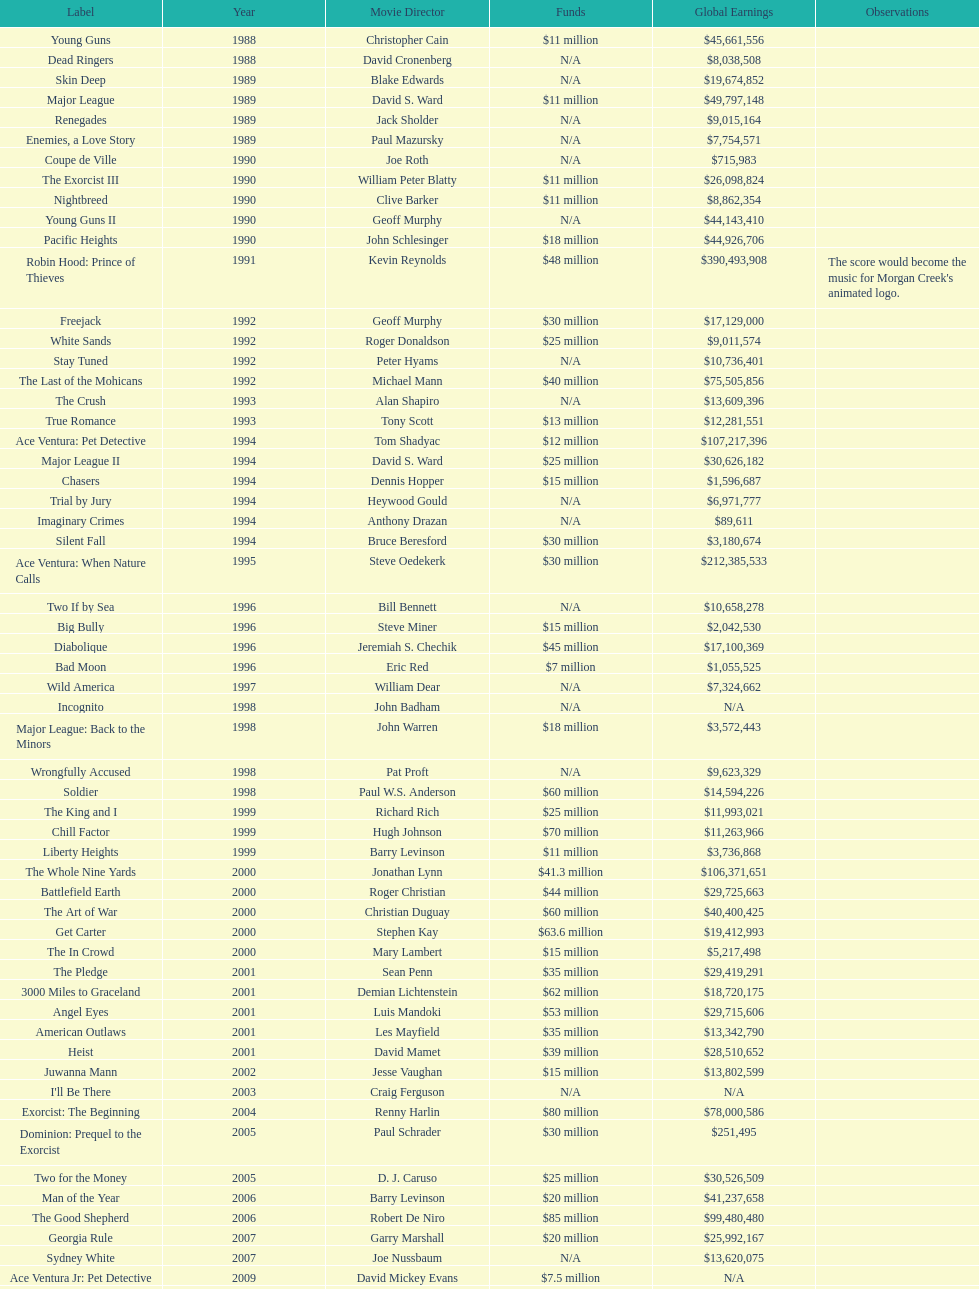What is the top grossing film? Robin Hood: Prince of Thieves. 